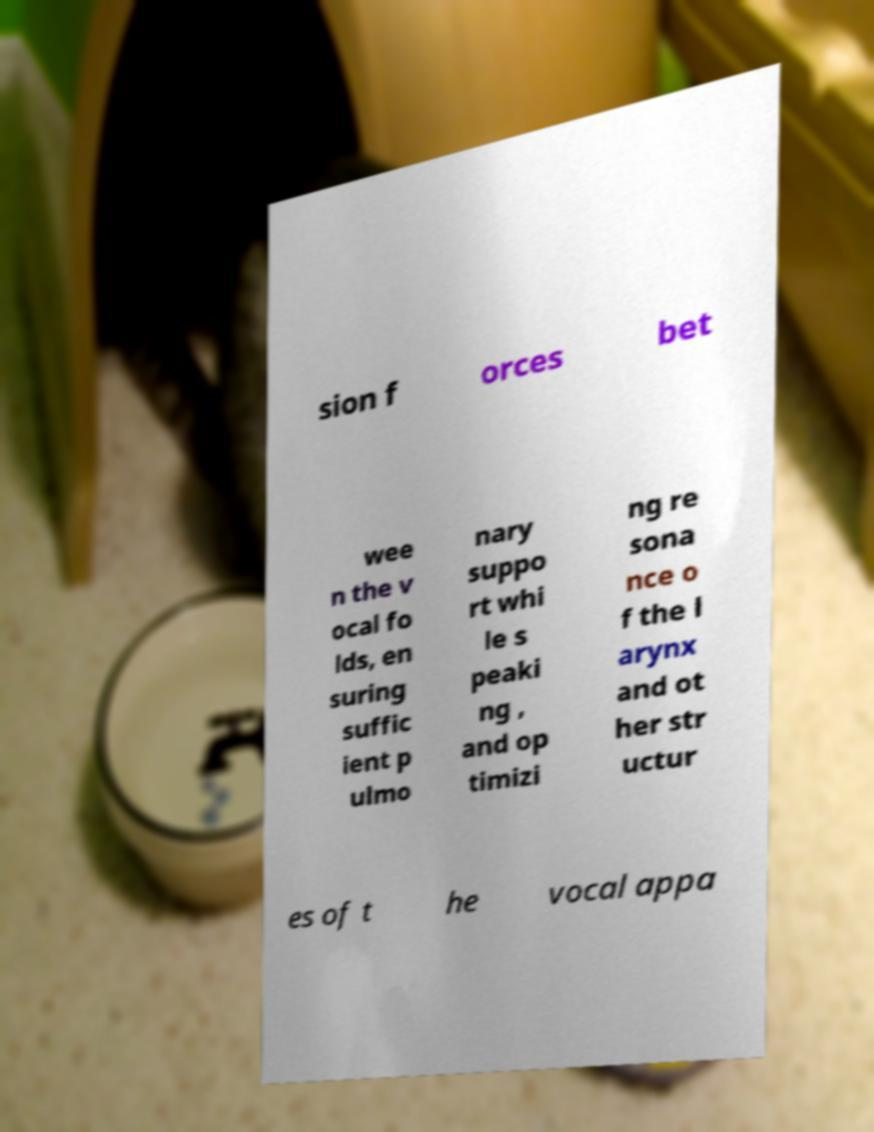Can you accurately transcribe the text from the provided image for me? sion f orces bet wee n the v ocal fo lds, en suring suffic ient p ulmo nary suppo rt whi le s peaki ng , and op timizi ng re sona nce o f the l arynx and ot her str uctur es of t he vocal appa 